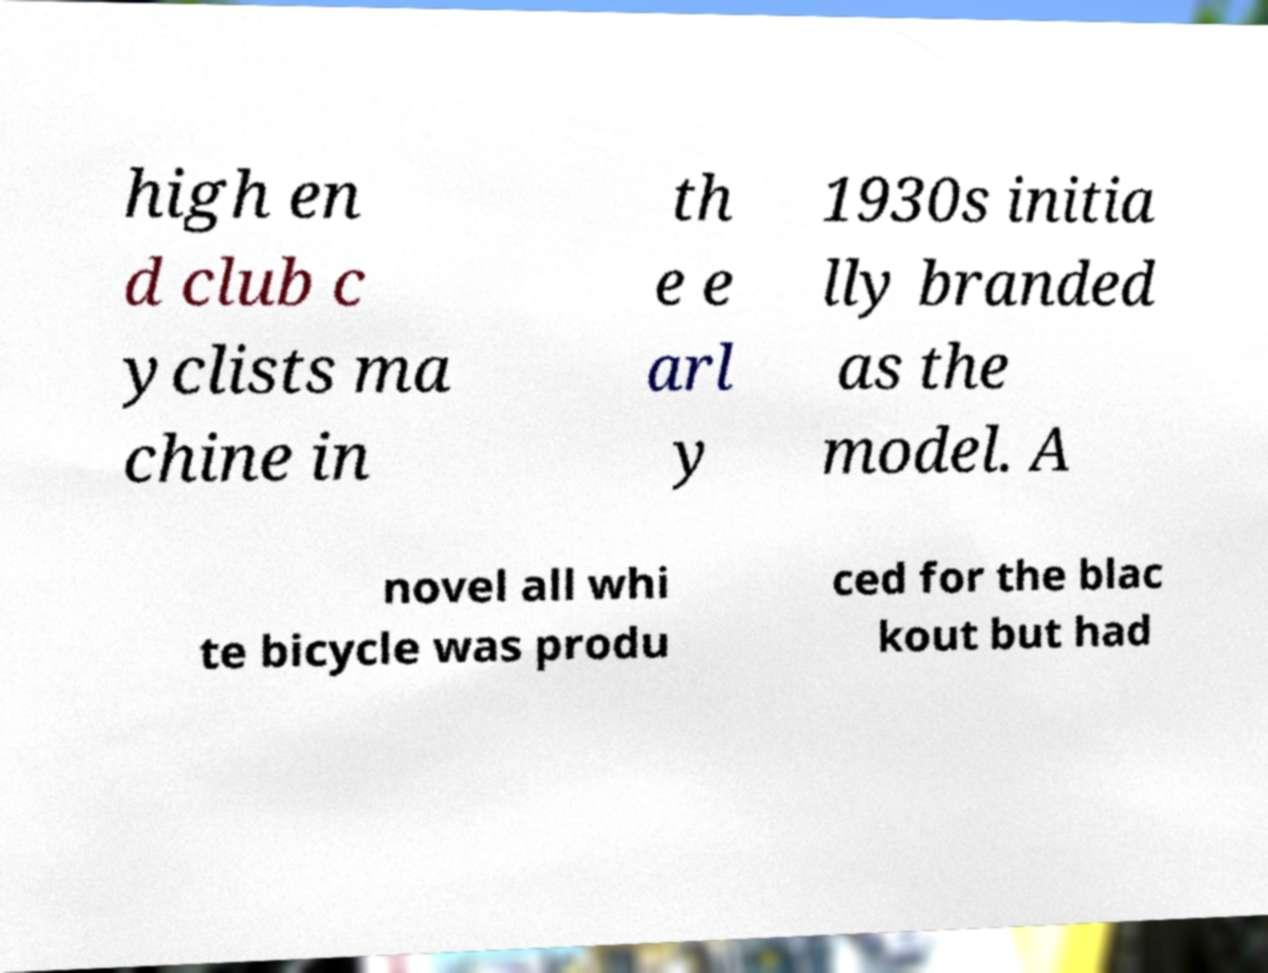I need the written content from this picture converted into text. Can you do that? high en d club c yclists ma chine in th e e arl y 1930s initia lly branded as the model. A novel all whi te bicycle was produ ced for the blac kout but had 